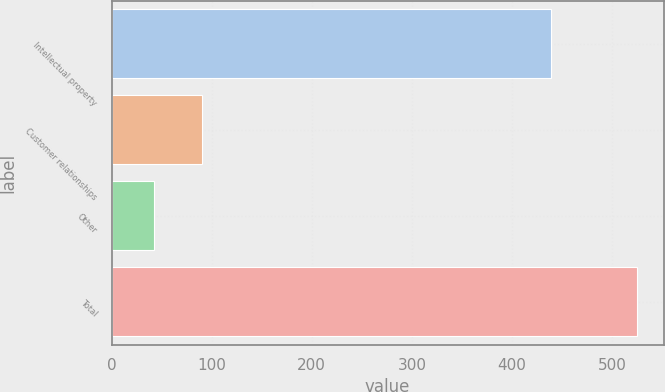Convert chart to OTSL. <chart><loc_0><loc_0><loc_500><loc_500><bar_chart><fcel>Intellectual property<fcel>Customer relationships<fcel>Other<fcel>Total<nl><fcel>439<fcel>90.3<fcel>42<fcel>525<nl></chart> 